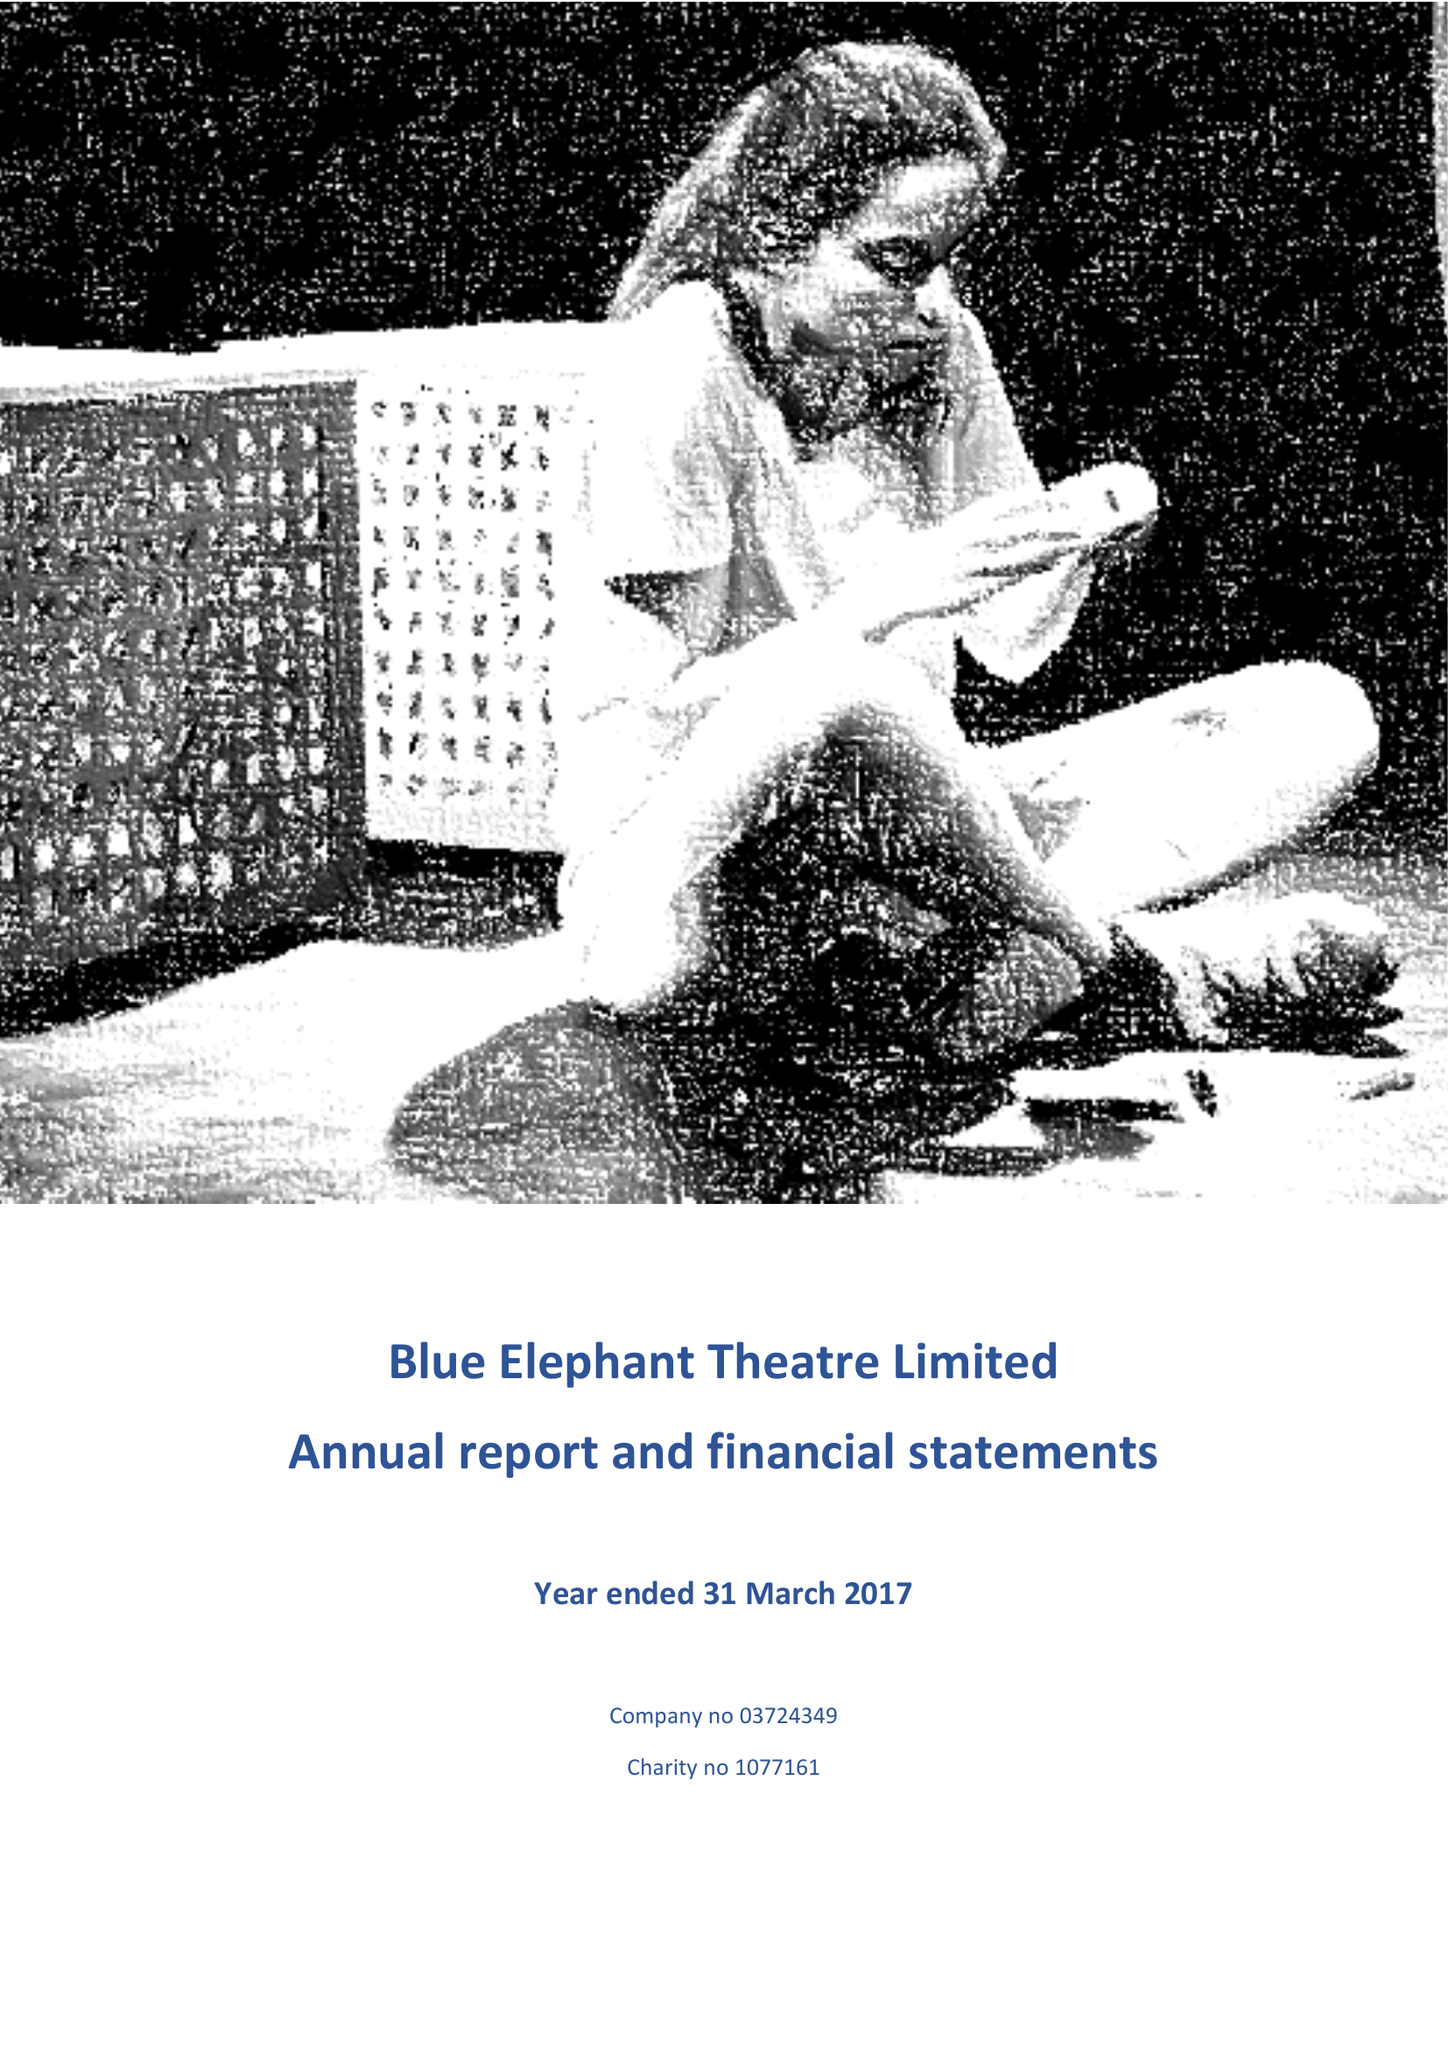What is the value for the address__street_line?
Answer the question using a single word or phrase. 59A BETHWIN ROAD 